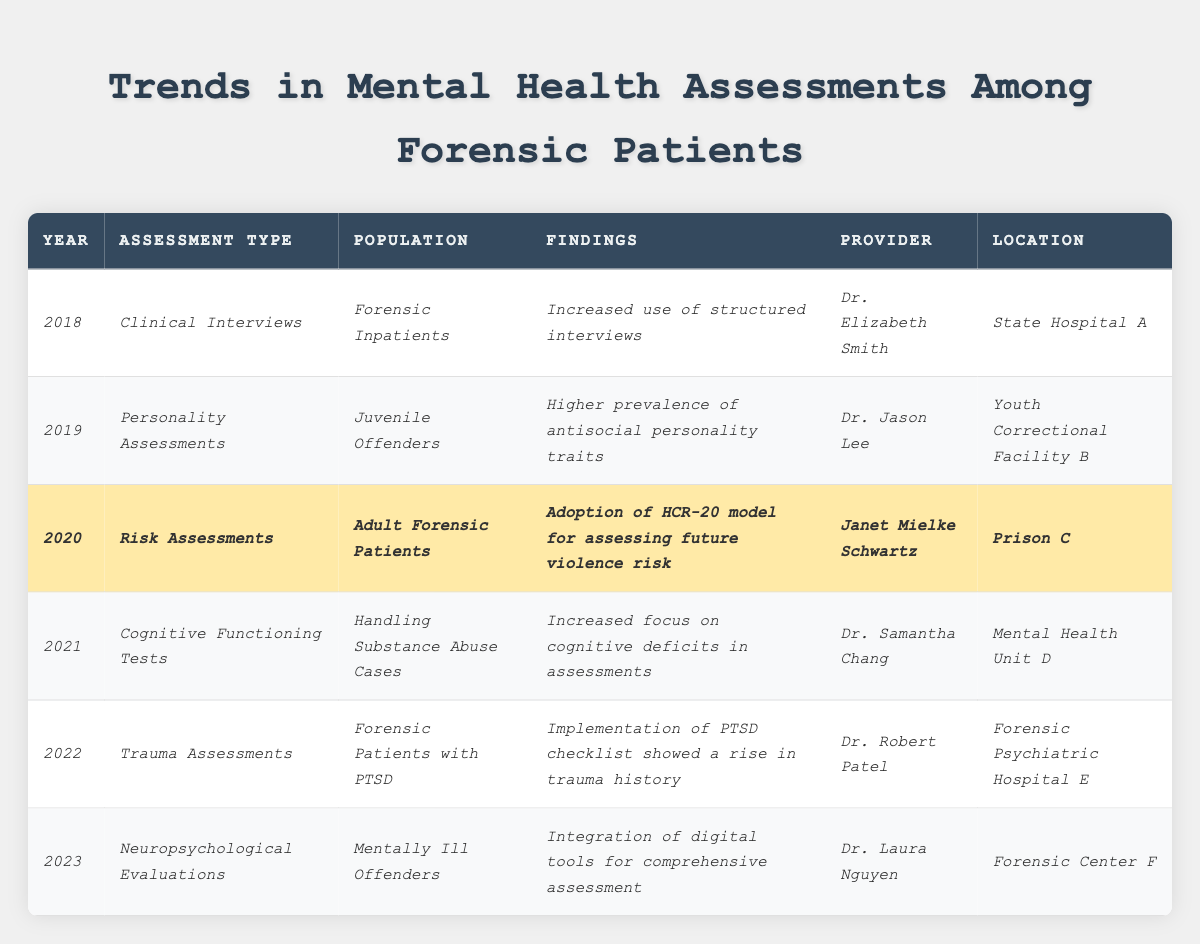What year did the adoption of the HCR-20 model for assessing future violence risk occur? The HCR-20 model was adopted in 2020, as indicated in the findings for that year.
Answer: 2020 Who conducted trauma assessments for forensic patients with PTSD? The trauma assessments for forensic patients with PTSD were conducted by Dr. Robert Patel, as stated in the table.
Answer: Dr. Robert Patel In which location did Dr. Jason Lee provide personality assessments? Dr. Jason Lee conducted personality assessments in Youth Correctional Facility B, as per the data listed in the table.
Answer: Youth Correctional Facility B What is the trend regarding cognitive functioning tests from 2020 to 2021? The trend shows an increased focus on cognitive deficits in assessments for the year 2021 compared to the focus in previous years, specifically notable in the 2021 data for handling substance abuse cases.
Answer: Increased focus on cognitive deficits What type of assessment was predominantly used for juvenile offenders in 2019? The predominant assessment type used for juvenile offenders in 2019 was Personality Assessments.
Answer: Personality Assessments Which assessment year had the integration of digital tools for comprehensive evaluation? The year 2023 featured the integration of digital tools for neuropsychological evaluations, as stated in the data.
Answer: 2023 Was there an increase in the use of structured interviews among forensic inpatients in 2018? Yes, there was an increase in the use of structured interviews among forensic inpatients in 2018, as indicated in the findings for that year.
Answer: Yes How many different assessment types were conducted from 2018 to 2023? There are six different assessment types listed in the data from 2018 to 2023: Clinical Interviews, Personality Assessments, Risk Assessments, Cognitive Functioning Tests, Trauma Assessments, and Neuropsychological Evaluations.
Answer: 6 What findings were noted in 2022 regarding trauma history? The findings in 2022 indicated that the implementation of a PTSD checklist showed a rise in trauma history among forensic patients with PTSD.
Answer: Rise in trauma history Compare the focus on assessments from 2018 to 2023. From 2018 to 2023, there is a noticeable trend of evolving focus in assessments: starting with structured interviews in 2018, moving to personality traits in 2019, risk assessments in 2020, cognitive deficits in 2021, trauma assessments in 2022, and an integration of digital tools in 2023. This signifies a progressive improvement and adaptation in mental health assessments over the years.
Answer: Progressive improvement in assessment focus 